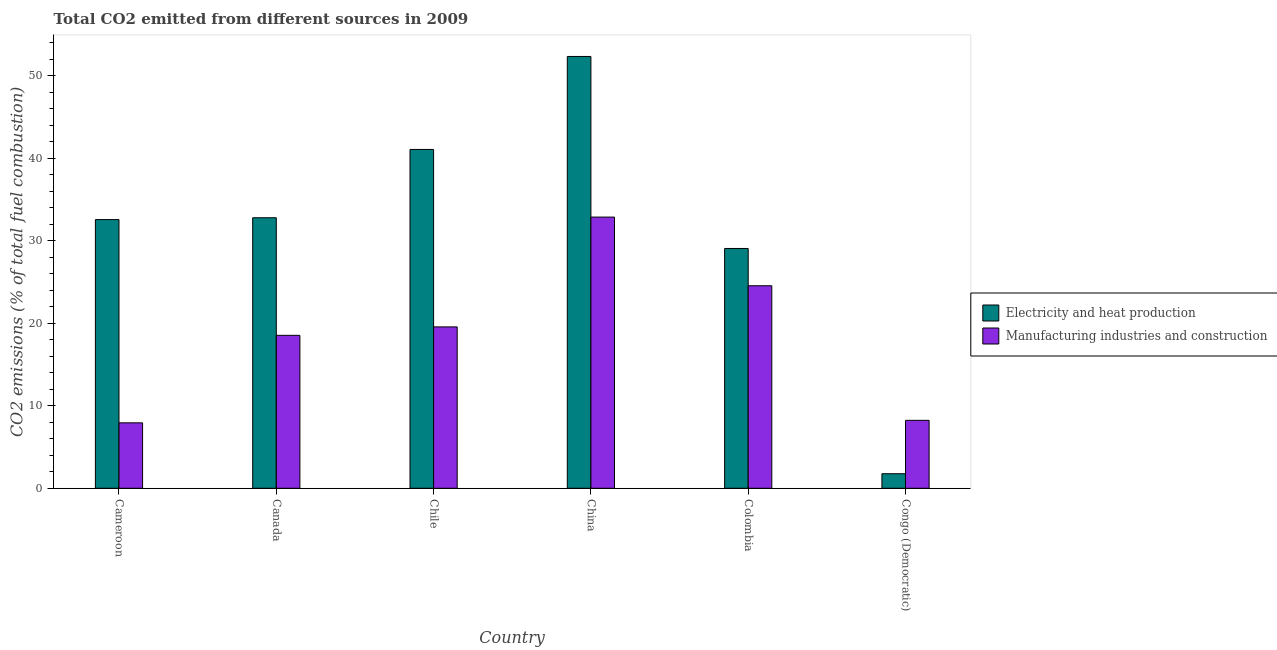How many groups of bars are there?
Your answer should be compact. 6. Are the number of bars per tick equal to the number of legend labels?
Your answer should be compact. Yes. Are the number of bars on each tick of the X-axis equal?
Give a very brief answer. Yes. How many bars are there on the 1st tick from the left?
Keep it short and to the point. 2. How many bars are there on the 6th tick from the right?
Provide a short and direct response. 2. What is the label of the 4th group of bars from the left?
Your response must be concise. China. In how many cases, is the number of bars for a given country not equal to the number of legend labels?
Provide a succinct answer. 0. What is the co2 emissions due to electricity and heat production in China?
Your answer should be very brief. 52.34. Across all countries, what is the maximum co2 emissions due to electricity and heat production?
Your response must be concise. 52.34. Across all countries, what is the minimum co2 emissions due to electricity and heat production?
Provide a succinct answer. 1.76. In which country was the co2 emissions due to electricity and heat production minimum?
Provide a succinct answer. Congo (Democratic). What is the total co2 emissions due to manufacturing industries in the graph?
Your response must be concise. 111.69. What is the difference between the co2 emissions due to electricity and heat production in Chile and that in Colombia?
Your answer should be very brief. 12. What is the difference between the co2 emissions due to manufacturing industries in Chile and the co2 emissions due to electricity and heat production in Congo (Democratic)?
Make the answer very short. 17.8. What is the average co2 emissions due to manufacturing industries per country?
Make the answer very short. 18.61. What is the difference between the co2 emissions due to manufacturing industries and co2 emissions due to electricity and heat production in Congo (Democratic)?
Provide a succinct answer. 6.47. In how many countries, is the co2 emissions due to manufacturing industries greater than 30 %?
Your answer should be very brief. 1. What is the ratio of the co2 emissions due to electricity and heat production in Canada to that in Colombia?
Make the answer very short. 1.13. Is the co2 emissions due to electricity and heat production in Cameroon less than that in Colombia?
Your response must be concise. No. Is the difference between the co2 emissions due to electricity and heat production in Canada and Chile greater than the difference between the co2 emissions due to manufacturing industries in Canada and Chile?
Provide a succinct answer. No. What is the difference between the highest and the second highest co2 emissions due to electricity and heat production?
Provide a succinct answer. 11.27. What is the difference between the highest and the lowest co2 emissions due to electricity and heat production?
Offer a terse response. 50.58. In how many countries, is the co2 emissions due to manufacturing industries greater than the average co2 emissions due to manufacturing industries taken over all countries?
Your response must be concise. 3. Is the sum of the co2 emissions due to manufacturing industries in Canada and Chile greater than the maximum co2 emissions due to electricity and heat production across all countries?
Your response must be concise. No. What does the 2nd bar from the left in Congo (Democratic) represents?
Your response must be concise. Manufacturing industries and construction. What does the 2nd bar from the right in Canada represents?
Your answer should be very brief. Electricity and heat production. How many bars are there?
Provide a short and direct response. 12. Are all the bars in the graph horizontal?
Give a very brief answer. No. What is the difference between two consecutive major ticks on the Y-axis?
Give a very brief answer. 10. Does the graph contain grids?
Give a very brief answer. No. Where does the legend appear in the graph?
Ensure brevity in your answer.  Center right. How are the legend labels stacked?
Ensure brevity in your answer.  Vertical. What is the title of the graph?
Your answer should be compact. Total CO2 emitted from different sources in 2009. Does "Investment in Transport" appear as one of the legend labels in the graph?
Provide a succinct answer. No. What is the label or title of the X-axis?
Keep it short and to the point. Country. What is the label or title of the Y-axis?
Keep it short and to the point. CO2 emissions (% of total fuel combustion). What is the CO2 emissions (% of total fuel combustion) of Electricity and heat production in Cameroon?
Your answer should be compact. 32.57. What is the CO2 emissions (% of total fuel combustion) in Manufacturing industries and construction in Cameroon?
Offer a very short reply. 7.93. What is the CO2 emissions (% of total fuel combustion) in Electricity and heat production in Canada?
Your response must be concise. 32.79. What is the CO2 emissions (% of total fuel combustion) of Manufacturing industries and construction in Canada?
Give a very brief answer. 18.54. What is the CO2 emissions (% of total fuel combustion) in Electricity and heat production in Chile?
Ensure brevity in your answer.  41.07. What is the CO2 emissions (% of total fuel combustion) in Manufacturing industries and construction in Chile?
Make the answer very short. 19.56. What is the CO2 emissions (% of total fuel combustion) of Electricity and heat production in China?
Offer a very short reply. 52.34. What is the CO2 emissions (% of total fuel combustion) in Manufacturing industries and construction in China?
Provide a succinct answer. 32.87. What is the CO2 emissions (% of total fuel combustion) in Electricity and heat production in Colombia?
Your response must be concise. 29.07. What is the CO2 emissions (% of total fuel combustion) in Manufacturing industries and construction in Colombia?
Give a very brief answer. 24.55. What is the CO2 emissions (% of total fuel combustion) in Electricity and heat production in Congo (Democratic)?
Provide a succinct answer. 1.76. What is the CO2 emissions (% of total fuel combustion) in Manufacturing industries and construction in Congo (Democratic)?
Your answer should be very brief. 8.24. Across all countries, what is the maximum CO2 emissions (% of total fuel combustion) in Electricity and heat production?
Your answer should be very brief. 52.34. Across all countries, what is the maximum CO2 emissions (% of total fuel combustion) in Manufacturing industries and construction?
Keep it short and to the point. 32.87. Across all countries, what is the minimum CO2 emissions (% of total fuel combustion) of Electricity and heat production?
Provide a short and direct response. 1.76. Across all countries, what is the minimum CO2 emissions (% of total fuel combustion) in Manufacturing industries and construction?
Give a very brief answer. 7.93. What is the total CO2 emissions (% of total fuel combustion) in Electricity and heat production in the graph?
Keep it short and to the point. 189.6. What is the total CO2 emissions (% of total fuel combustion) in Manufacturing industries and construction in the graph?
Your response must be concise. 111.69. What is the difference between the CO2 emissions (% of total fuel combustion) of Electricity and heat production in Cameroon and that in Canada?
Your response must be concise. -0.22. What is the difference between the CO2 emissions (% of total fuel combustion) of Manufacturing industries and construction in Cameroon and that in Canada?
Ensure brevity in your answer.  -10.61. What is the difference between the CO2 emissions (% of total fuel combustion) of Electricity and heat production in Cameroon and that in Chile?
Offer a terse response. -8.5. What is the difference between the CO2 emissions (% of total fuel combustion) of Manufacturing industries and construction in Cameroon and that in Chile?
Provide a short and direct response. -11.63. What is the difference between the CO2 emissions (% of total fuel combustion) of Electricity and heat production in Cameroon and that in China?
Provide a short and direct response. -19.77. What is the difference between the CO2 emissions (% of total fuel combustion) in Manufacturing industries and construction in Cameroon and that in China?
Your response must be concise. -24.94. What is the difference between the CO2 emissions (% of total fuel combustion) of Electricity and heat production in Cameroon and that in Colombia?
Offer a very short reply. 3.5. What is the difference between the CO2 emissions (% of total fuel combustion) in Manufacturing industries and construction in Cameroon and that in Colombia?
Make the answer very short. -16.61. What is the difference between the CO2 emissions (% of total fuel combustion) in Electricity and heat production in Cameroon and that in Congo (Democratic)?
Give a very brief answer. 30.8. What is the difference between the CO2 emissions (% of total fuel combustion) in Manufacturing industries and construction in Cameroon and that in Congo (Democratic)?
Make the answer very short. -0.3. What is the difference between the CO2 emissions (% of total fuel combustion) of Electricity and heat production in Canada and that in Chile?
Provide a short and direct response. -8.28. What is the difference between the CO2 emissions (% of total fuel combustion) in Manufacturing industries and construction in Canada and that in Chile?
Provide a succinct answer. -1.02. What is the difference between the CO2 emissions (% of total fuel combustion) of Electricity and heat production in Canada and that in China?
Keep it short and to the point. -19.55. What is the difference between the CO2 emissions (% of total fuel combustion) in Manufacturing industries and construction in Canada and that in China?
Your answer should be compact. -14.33. What is the difference between the CO2 emissions (% of total fuel combustion) of Electricity and heat production in Canada and that in Colombia?
Your answer should be very brief. 3.72. What is the difference between the CO2 emissions (% of total fuel combustion) of Manufacturing industries and construction in Canada and that in Colombia?
Provide a succinct answer. -6.01. What is the difference between the CO2 emissions (% of total fuel combustion) of Electricity and heat production in Canada and that in Congo (Democratic)?
Offer a terse response. 31.02. What is the difference between the CO2 emissions (% of total fuel combustion) in Manufacturing industries and construction in Canada and that in Congo (Democratic)?
Ensure brevity in your answer.  10.3. What is the difference between the CO2 emissions (% of total fuel combustion) in Electricity and heat production in Chile and that in China?
Keep it short and to the point. -11.27. What is the difference between the CO2 emissions (% of total fuel combustion) in Manufacturing industries and construction in Chile and that in China?
Your response must be concise. -13.31. What is the difference between the CO2 emissions (% of total fuel combustion) of Electricity and heat production in Chile and that in Colombia?
Your response must be concise. 12. What is the difference between the CO2 emissions (% of total fuel combustion) in Manufacturing industries and construction in Chile and that in Colombia?
Offer a very short reply. -4.99. What is the difference between the CO2 emissions (% of total fuel combustion) in Electricity and heat production in Chile and that in Congo (Democratic)?
Offer a terse response. 39.3. What is the difference between the CO2 emissions (% of total fuel combustion) of Manufacturing industries and construction in Chile and that in Congo (Democratic)?
Offer a terse response. 11.33. What is the difference between the CO2 emissions (% of total fuel combustion) of Electricity and heat production in China and that in Colombia?
Offer a very short reply. 23.27. What is the difference between the CO2 emissions (% of total fuel combustion) of Manufacturing industries and construction in China and that in Colombia?
Offer a terse response. 8.32. What is the difference between the CO2 emissions (% of total fuel combustion) in Electricity and heat production in China and that in Congo (Democratic)?
Offer a terse response. 50.58. What is the difference between the CO2 emissions (% of total fuel combustion) in Manufacturing industries and construction in China and that in Congo (Democratic)?
Offer a terse response. 24.64. What is the difference between the CO2 emissions (% of total fuel combustion) of Electricity and heat production in Colombia and that in Congo (Democratic)?
Make the answer very short. 27.3. What is the difference between the CO2 emissions (% of total fuel combustion) of Manufacturing industries and construction in Colombia and that in Congo (Democratic)?
Offer a very short reply. 16.31. What is the difference between the CO2 emissions (% of total fuel combustion) of Electricity and heat production in Cameroon and the CO2 emissions (% of total fuel combustion) of Manufacturing industries and construction in Canada?
Provide a short and direct response. 14.03. What is the difference between the CO2 emissions (% of total fuel combustion) in Electricity and heat production in Cameroon and the CO2 emissions (% of total fuel combustion) in Manufacturing industries and construction in Chile?
Ensure brevity in your answer.  13.01. What is the difference between the CO2 emissions (% of total fuel combustion) in Electricity and heat production in Cameroon and the CO2 emissions (% of total fuel combustion) in Manufacturing industries and construction in China?
Offer a terse response. -0.3. What is the difference between the CO2 emissions (% of total fuel combustion) in Electricity and heat production in Cameroon and the CO2 emissions (% of total fuel combustion) in Manufacturing industries and construction in Colombia?
Give a very brief answer. 8.02. What is the difference between the CO2 emissions (% of total fuel combustion) in Electricity and heat production in Cameroon and the CO2 emissions (% of total fuel combustion) in Manufacturing industries and construction in Congo (Democratic)?
Provide a short and direct response. 24.33. What is the difference between the CO2 emissions (% of total fuel combustion) of Electricity and heat production in Canada and the CO2 emissions (% of total fuel combustion) of Manufacturing industries and construction in Chile?
Make the answer very short. 13.23. What is the difference between the CO2 emissions (% of total fuel combustion) of Electricity and heat production in Canada and the CO2 emissions (% of total fuel combustion) of Manufacturing industries and construction in China?
Provide a succinct answer. -0.08. What is the difference between the CO2 emissions (% of total fuel combustion) in Electricity and heat production in Canada and the CO2 emissions (% of total fuel combustion) in Manufacturing industries and construction in Colombia?
Your answer should be compact. 8.24. What is the difference between the CO2 emissions (% of total fuel combustion) in Electricity and heat production in Canada and the CO2 emissions (% of total fuel combustion) in Manufacturing industries and construction in Congo (Democratic)?
Your answer should be very brief. 24.55. What is the difference between the CO2 emissions (% of total fuel combustion) of Electricity and heat production in Chile and the CO2 emissions (% of total fuel combustion) of Manufacturing industries and construction in China?
Keep it short and to the point. 8.2. What is the difference between the CO2 emissions (% of total fuel combustion) in Electricity and heat production in Chile and the CO2 emissions (% of total fuel combustion) in Manufacturing industries and construction in Colombia?
Ensure brevity in your answer.  16.52. What is the difference between the CO2 emissions (% of total fuel combustion) of Electricity and heat production in Chile and the CO2 emissions (% of total fuel combustion) of Manufacturing industries and construction in Congo (Democratic)?
Your answer should be very brief. 32.83. What is the difference between the CO2 emissions (% of total fuel combustion) in Electricity and heat production in China and the CO2 emissions (% of total fuel combustion) in Manufacturing industries and construction in Colombia?
Make the answer very short. 27.79. What is the difference between the CO2 emissions (% of total fuel combustion) of Electricity and heat production in China and the CO2 emissions (% of total fuel combustion) of Manufacturing industries and construction in Congo (Democratic)?
Ensure brevity in your answer.  44.1. What is the difference between the CO2 emissions (% of total fuel combustion) of Electricity and heat production in Colombia and the CO2 emissions (% of total fuel combustion) of Manufacturing industries and construction in Congo (Democratic)?
Offer a very short reply. 20.83. What is the average CO2 emissions (% of total fuel combustion) of Electricity and heat production per country?
Your answer should be very brief. 31.6. What is the average CO2 emissions (% of total fuel combustion) in Manufacturing industries and construction per country?
Provide a succinct answer. 18.61. What is the difference between the CO2 emissions (% of total fuel combustion) of Electricity and heat production and CO2 emissions (% of total fuel combustion) of Manufacturing industries and construction in Cameroon?
Provide a succinct answer. 24.63. What is the difference between the CO2 emissions (% of total fuel combustion) in Electricity and heat production and CO2 emissions (% of total fuel combustion) in Manufacturing industries and construction in Canada?
Provide a succinct answer. 14.25. What is the difference between the CO2 emissions (% of total fuel combustion) of Electricity and heat production and CO2 emissions (% of total fuel combustion) of Manufacturing industries and construction in Chile?
Provide a short and direct response. 21.51. What is the difference between the CO2 emissions (% of total fuel combustion) of Electricity and heat production and CO2 emissions (% of total fuel combustion) of Manufacturing industries and construction in China?
Your answer should be compact. 19.47. What is the difference between the CO2 emissions (% of total fuel combustion) in Electricity and heat production and CO2 emissions (% of total fuel combustion) in Manufacturing industries and construction in Colombia?
Your answer should be very brief. 4.52. What is the difference between the CO2 emissions (% of total fuel combustion) in Electricity and heat production and CO2 emissions (% of total fuel combustion) in Manufacturing industries and construction in Congo (Democratic)?
Your answer should be very brief. -6.47. What is the ratio of the CO2 emissions (% of total fuel combustion) in Manufacturing industries and construction in Cameroon to that in Canada?
Make the answer very short. 0.43. What is the ratio of the CO2 emissions (% of total fuel combustion) in Electricity and heat production in Cameroon to that in Chile?
Offer a very short reply. 0.79. What is the ratio of the CO2 emissions (% of total fuel combustion) of Manufacturing industries and construction in Cameroon to that in Chile?
Your answer should be very brief. 0.41. What is the ratio of the CO2 emissions (% of total fuel combustion) of Electricity and heat production in Cameroon to that in China?
Ensure brevity in your answer.  0.62. What is the ratio of the CO2 emissions (% of total fuel combustion) in Manufacturing industries and construction in Cameroon to that in China?
Provide a succinct answer. 0.24. What is the ratio of the CO2 emissions (% of total fuel combustion) of Electricity and heat production in Cameroon to that in Colombia?
Provide a short and direct response. 1.12. What is the ratio of the CO2 emissions (% of total fuel combustion) of Manufacturing industries and construction in Cameroon to that in Colombia?
Make the answer very short. 0.32. What is the ratio of the CO2 emissions (% of total fuel combustion) of Electricity and heat production in Cameroon to that in Congo (Democratic)?
Provide a succinct answer. 18.46. What is the ratio of the CO2 emissions (% of total fuel combustion) in Manufacturing industries and construction in Cameroon to that in Congo (Democratic)?
Your answer should be compact. 0.96. What is the ratio of the CO2 emissions (% of total fuel combustion) of Electricity and heat production in Canada to that in Chile?
Ensure brevity in your answer.  0.8. What is the ratio of the CO2 emissions (% of total fuel combustion) of Manufacturing industries and construction in Canada to that in Chile?
Provide a short and direct response. 0.95. What is the ratio of the CO2 emissions (% of total fuel combustion) in Electricity and heat production in Canada to that in China?
Ensure brevity in your answer.  0.63. What is the ratio of the CO2 emissions (% of total fuel combustion) of Manufacturing industries and construction in Canada to that in China?
Offer a very short reply. 0.56. What is the ratio of the CO2 emissions (% of total fuel combustion) in Electricity and heat production in Canada to that in Colombia?
Give a very brief answer. 1.13. What is the ratio of the CO2 emissions (% of total fuel combustion) in Manufacturing industries and construction in Canada to that in Colombia?
Provide a succinct answer. 0.76. What is the ratio of the CO2 emissions (% of total fuel combustion) of Electricity and heat production in Canada to that in Congo (Democratic)?
Ensure brevity in your answer.  18.58. What is the ratio of the CO2 emissions (% of total fuel combustion) in Manufacturing industries and construction in Canada to that in Congo (Democratic)?
Your response must be concise. 2.25. What is the ratio of the CO2 emissions (% of total fuel combustion) of Electricity and heat production in Chile to that in China?
Keep it short and to the point. 0.78. What is the ratio of the CO2 emissions (% of total fuel combustion) in Manufacturing industries and construction in Chile to that in China?
Offer a very short reply. 0.6. What is the ratio of the CO2 emissions (% of total fuel combustion) of Electricity and heat production in Chile to that in Colombia?
Your answer should be very brief. 1.41. What is the ratio of the CO2 emissions (% of total fuel combustion) in Manufacturing industries and construction in Chile to that in Colombia?
Offer a very short reply. 0.8. What is the ratio of the CO2 emissions (% of total fuel combustion) in Electricity and heat production in Chile to that in Congo (Democratic)?
Offer a terse response. 23.27. What is the ratio of the CO2 emissions (% of total fuel combustion) of Manufacturing industries and construction in Chile to that in Congo (Democratic)?
Your response must be concise. 2.38. What is the ratio of the CO2 emissions (% of total fuel combustion) of Electricity and heat production in China to that in Colombia?
Your response must be concise. 1.8. What is the ratio of the CO2 emissions (% of total fuel combustion) of Manufacturing industries and construction in China to that in Colombia?
Provide a short and direct response. 1.34. What is the ratio of the CO2 emissions (% of total fuel combustion) of Electricity and heat production in China to that in Congo (Democratic)?
Give a very brief answer. 29.66. What is the ratio of the CO2 emissions (% of total fuel combustion) in Manufacturing industries and construction in China to that in Congo (Democratic)?
Offer a very short reply. 3.99. What is the ratio of the CO2 emissions (% of total fuel combustion) in Electricity and heat production in Colombia to that in Congo (Democratic)?
Provide a short and direct response. 16.47. What is the ratio of the CO2 emissions (% of total fuel combustion) of Manufacturing industries and construction in Colombia to that in Congo (Democratic)?
Your response must be concise. 2.98. What is the difference between the highest and the second highest CO2 emissions (% of total fuel combustion) in Electricity and heat production?
Your response must be concise. 11.27. What is the difference between the highest and the second highest CO2 emissions (% of total fuel combustion) in Manufacturing industries and construction?
Your response must be concise. 8.32. What is the difference between the highest and the lowest CO2 emissions (% of total fuel combustion) in Electricity and heat production?
Give a very brief answer. 50.58. What is the difference between the highest and the lowest CO2 emissions (% of total fuel combustion) in Manufacturing industries and construction?
Offer a very short reply. 24.94. 